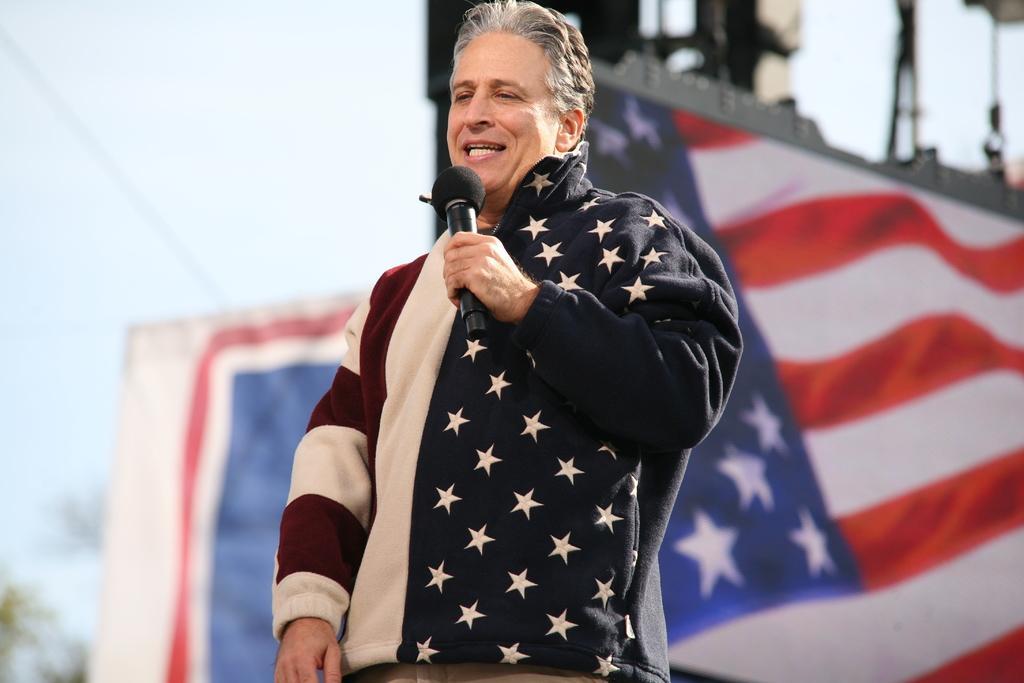In one or two sentences, can you explain what this image depicts? In this picture there is a man standing and talking and holding the microphone. At the back there is a flag and hoarding and there are lights on the pole. At the top there is sky and wire. On the left side of the image there is a tree. 